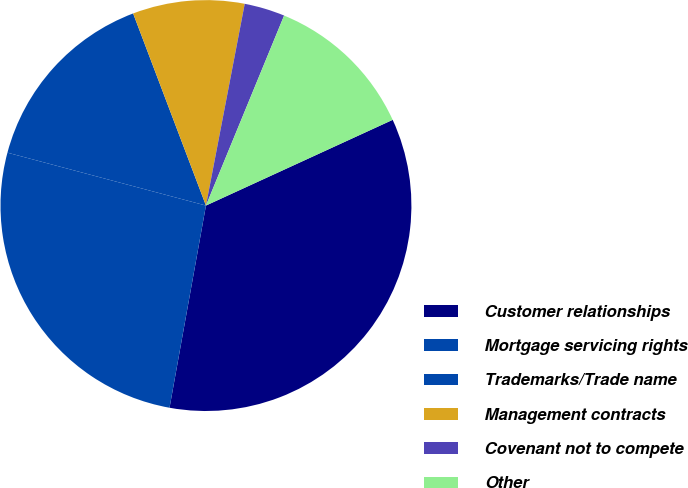Convert chart. <chart><loc_0><loc_0><loc_500><loc_500><pie_chart><fcel>Customer relationships<fcel>Mortgage servicing rights<fcel>Trademarks/Trade name<fcel>Management contracts<fcel>Covenant not to compete<fcel>Other<nl><fcel>34.69%<fcel>26.31%<fcel>15.09%<fcel>8.79%<fcel>3.19%<fcel>11.94%<nl></chart> 